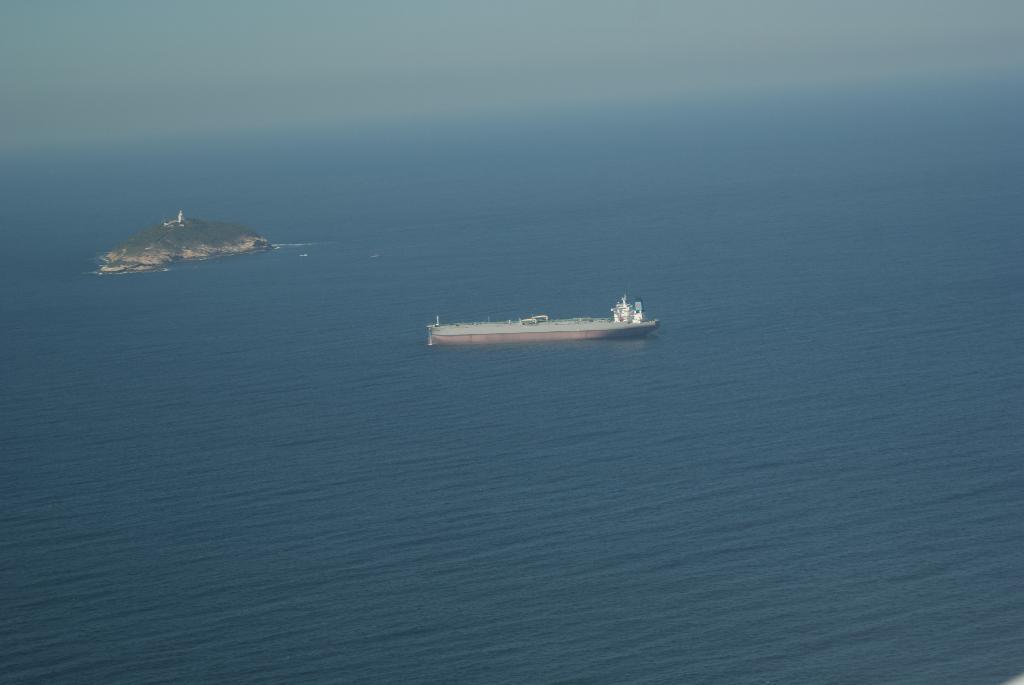How would you summarize this image in a sentence or two? In this picture we can see a ship on the water and behind the ship there is a land and a sky. 